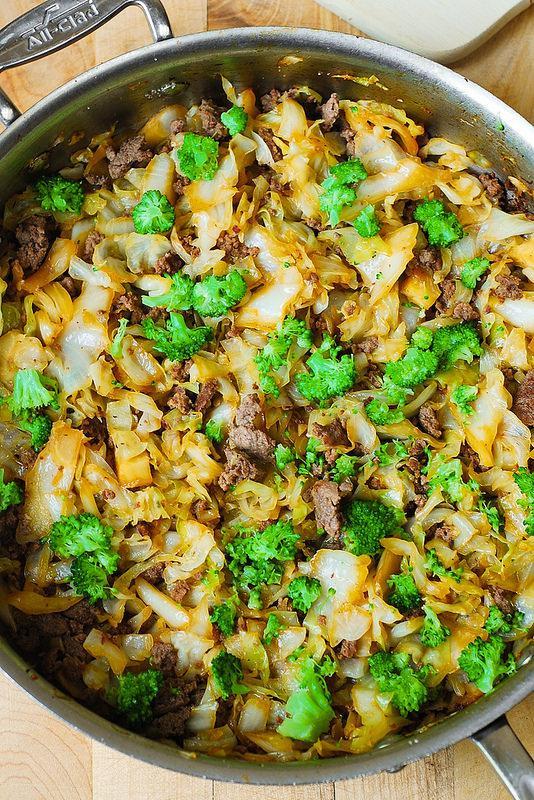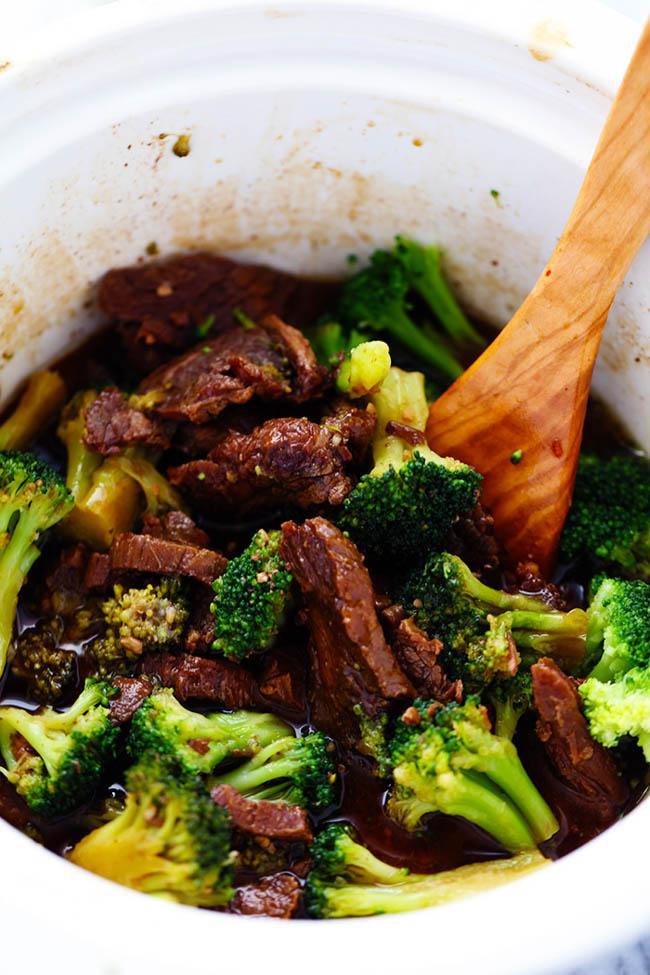The first image is the image on the left, the second image is the image on the right. Analyze the images presented: Is the assertion "Broccoli stir fry is being served in the center of two white plates." valid? Answer yes or no. No. The first image is the image on the left, the second image is the image on the right. For the images displayed, is the sentence "The left and right image contains the same number of white plates with broccoli and beef." factually correct? Answer yes or no. No. 